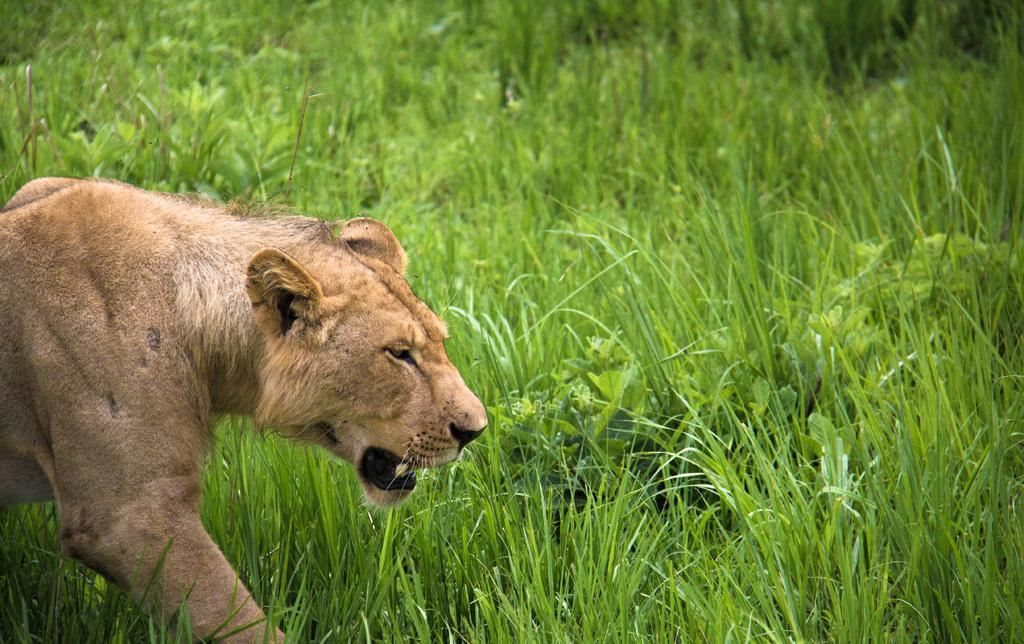What is the dominant feature of the landscape in the image? There is a lot of grass in the image. Can you describe any animals present in the image? There is a lion on the left side of the image. Is the lion an expert in sleeping in the image? There is no indication in the image that the lion is an expert in sleeping or any other activity. 